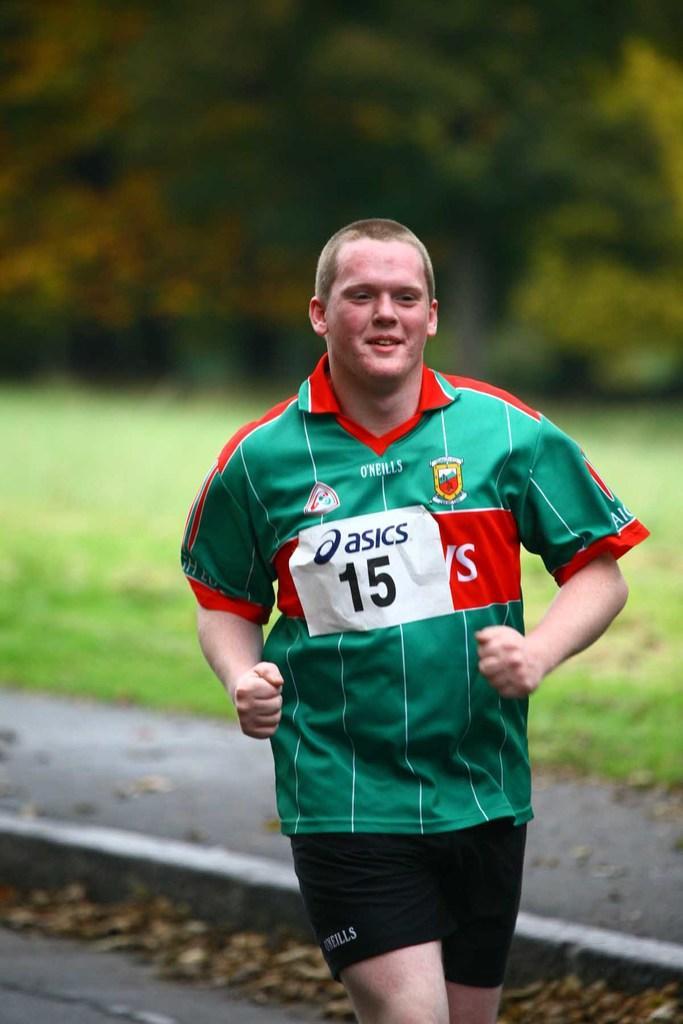Describe this image in one or two sentences. In this image in front there is a person running on the road. Behind him there is grass on the surface. In the background of the image there are trees. 